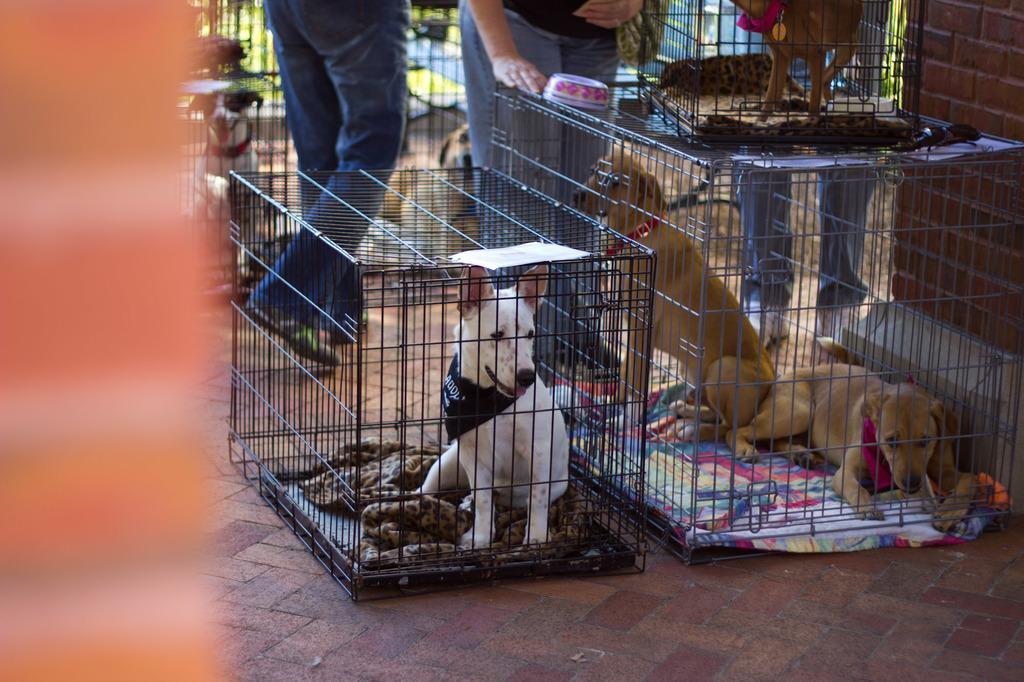Describe this image in one or two sentences. In this picture we can see dogs in cages and three people on the ground and in the background we can see grass and it is blurry. 